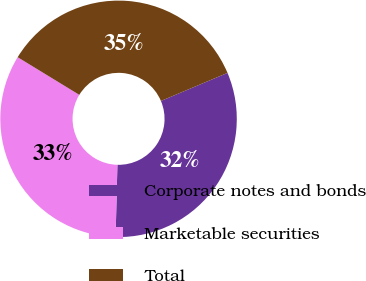<chart> <loc_0><loc_0><loc_500><loc_500><pie_chart><fcel>Corporate notes and bonds<fcel>Marketable securities<fcel>Total<nl><fcel>31.75%<fcel>33.33%<fcel>34.92%<nl></chart> 